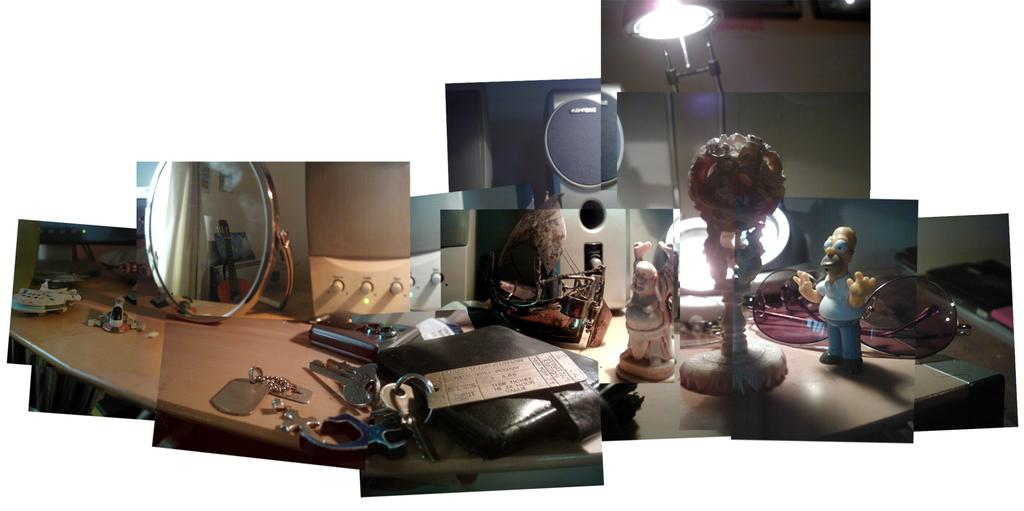What type of reflective surface is present in the image? There is a mirror in the image. What personal item can be seen in the image? There is a wallet in the image. What is used for unlocking or accessing something in the image? There are keys in the image. What type of playthings are present in the image? There are toys in the image. What source of light is present in the image? There is a lamp in the image. On what surface are all the objects placed in the image? All objects are on a table in the image. What color is the tiger's hair in the image? There is no tiger present in the image, so we cannot determine the color of its hair. How many eyes are visible in the image? The provided facts do not mention any eyes, so we cannot determine the number of eyes visible in the image. 